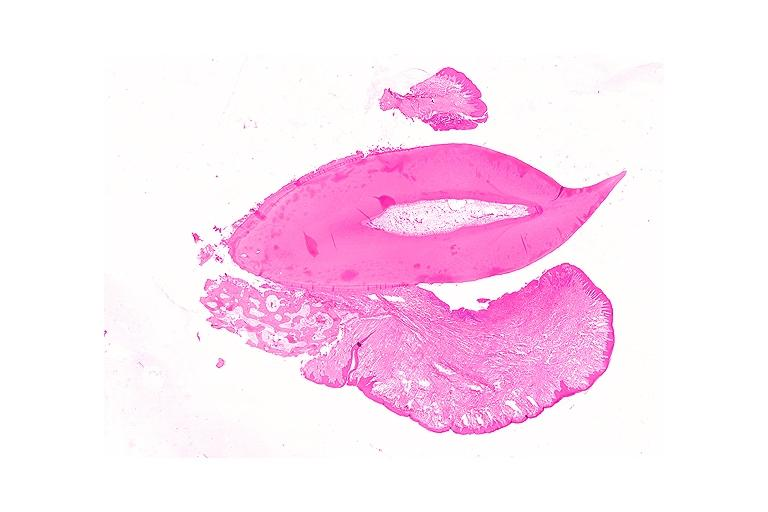s fibrous meningioma present?
Answer the question using a single word or phrase. No 